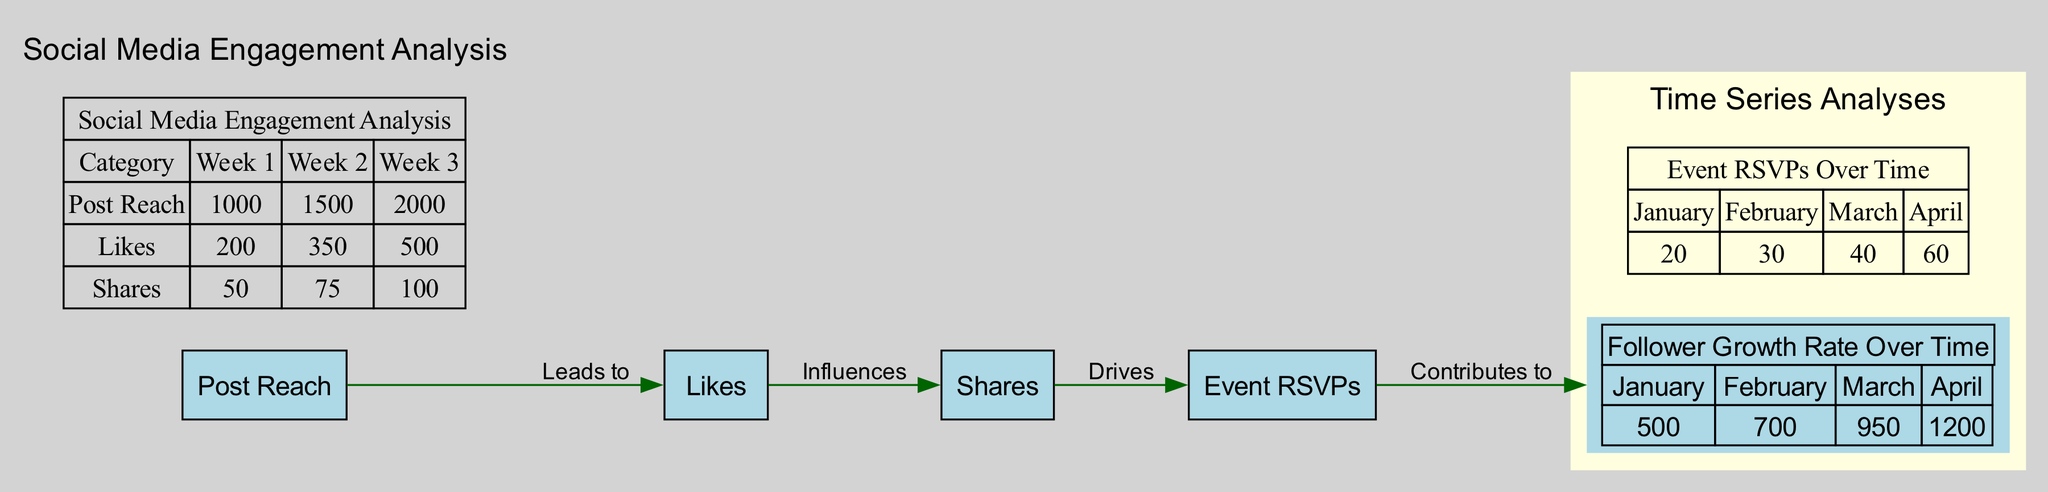What is the value of Post Reach in Week 3? The diagram shows a bubble chart for Post Reach, which lists values for different weeks. In Week 3, the value for Post Reach is explicitly given as 2000.
Answer: 2000 How many nodes are present in the diagram? The diagram includes nodes representing Post Reach, Likes, Shares, Event RSVPs, and Follower Growth Rate. Hence, there are a total of five nodes.
Answer: 5 What does Shares influence according to the diagram? The diagram outlines the relationships among the nodes, indicating that Shares influences Event RSVPs, as stated in the edges.
Answer: Event RSVPs What was the Follower Count in March? The time series graph for Follower Growth Rate shows values for each month. In March, the follower count is explicitly listed as 950.
Answer: 950 Which category had the highest value in Week 2? By examining the bubble chart for social media engagement metrics, the values for Week 2 are: Post Reach (1500), Likes (350), Shares (75). Post Reach has the highest value at 1500.
Answer: Post Reach How many edges connect the nodes in the diagram? The edges represent relationships between the nodes, and there are four edges linking the categorized nodes as described in the diagram.
Answer: 4 What contributes to Follower Growth Rate? The relationships drawn in the diagram indicate that Event RSVPs contribute to Follower Growth Rate, as specified by the edges connecting these nodes.
Answer: Event RSVPs What is the value of Event RSVPs in April? The time series graph for Event RSVPs indicates that in April, the RSVP count is explicitly shown as 60.
Answer: 60 In which month did the Follower Count exceed 1000? A careful review of the time series graph shows that the Follower Count first exceeds 1000 in April, with a listed value of 1200.
Answer: April 